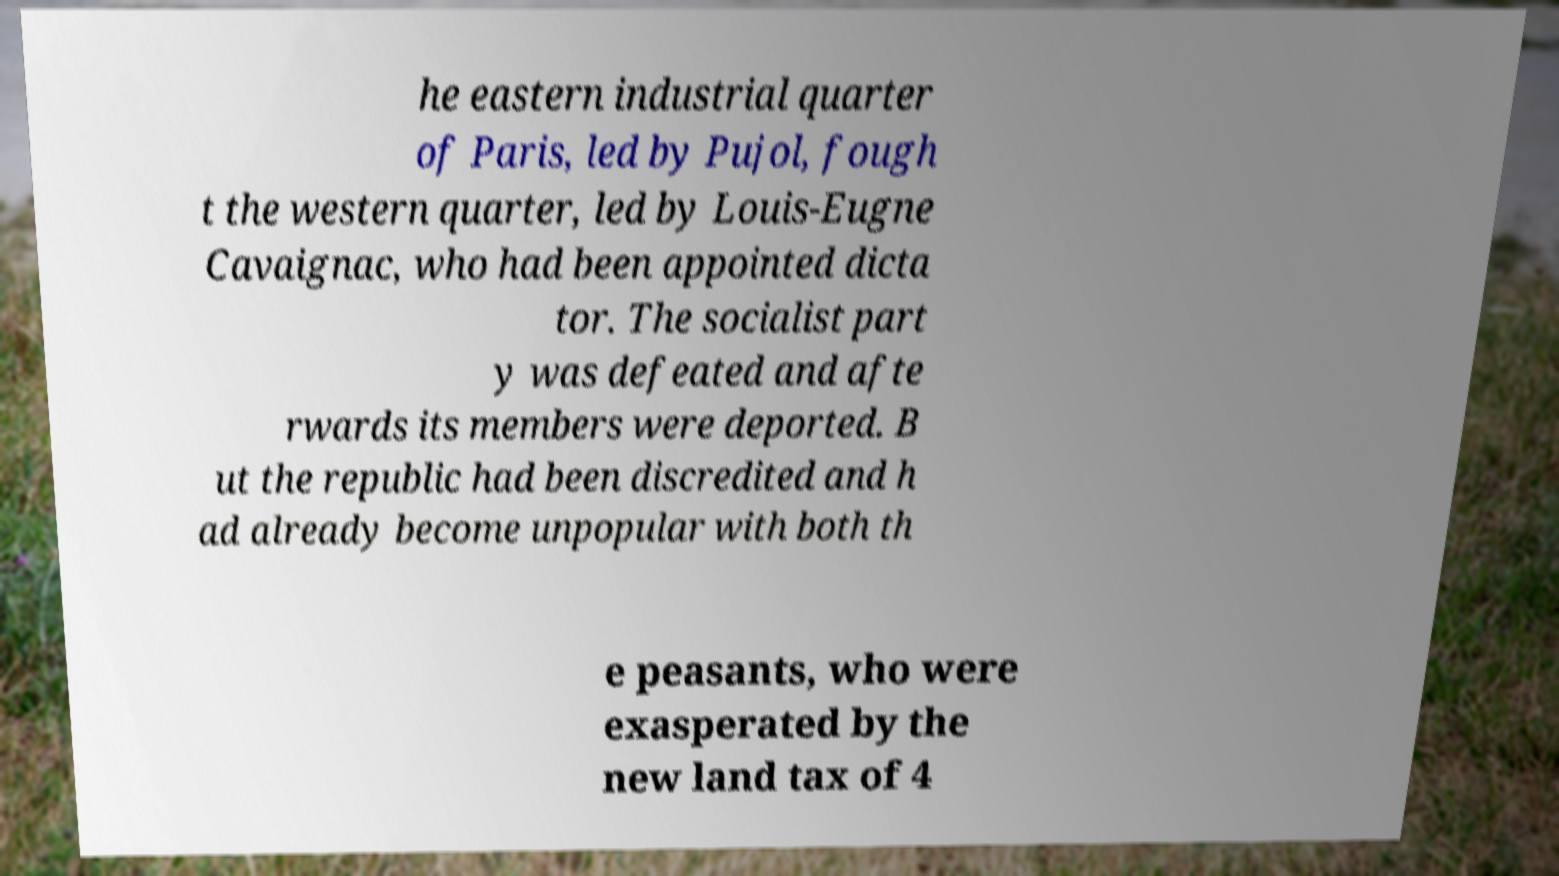Can you read and provide the text displayed in the image?This photo seems to have some interesting text. Can you extract and type it out for me? he eastern industrial quarter of Paris, led by Pujol, fough t the western quarter, led by Louis-Eugne Cavaignac, who had been appointed dicta tor. The socialist part y was defeated and afte rwards its members were deported. B ut the republic had been discredited and h ad already become unpopular with both th e peasants, who were exasperated by the new land tax of 4 